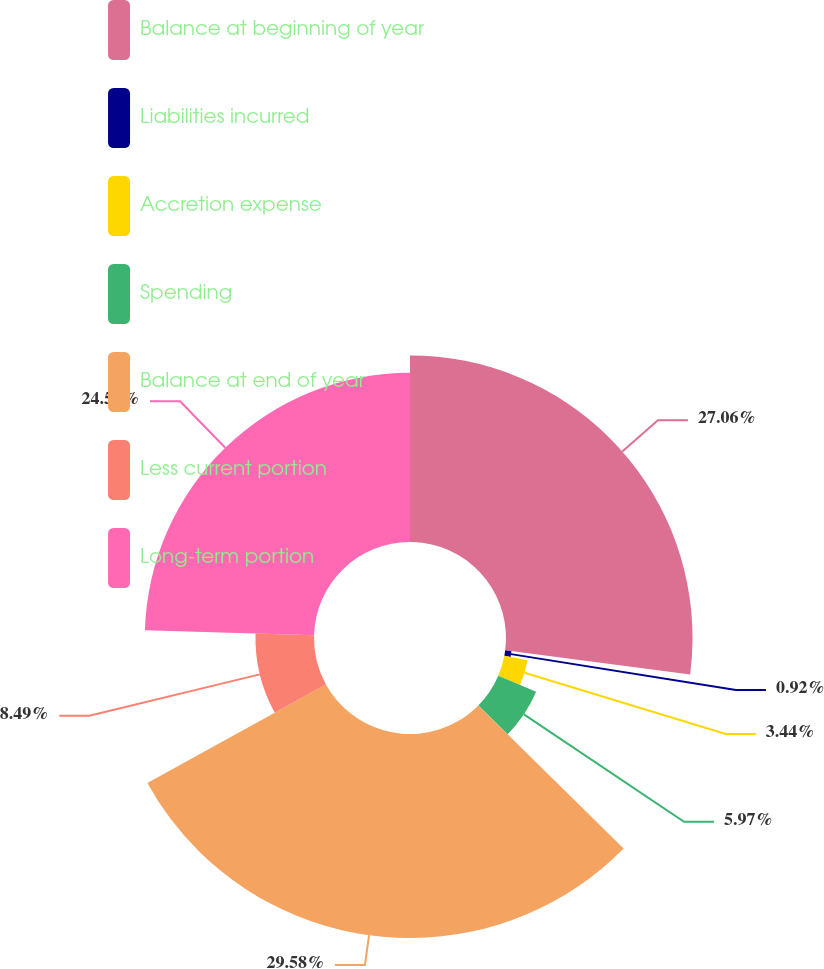Convert chart to OTSL. <chart><loc_0><loc_0><loc_500><loc_500><pie_chart><fcel>Balance at beginning of year<fcel>Liabilities incurred<fcel>Accretion expense<fcel>Spending<fcel>Balance at end of year<fcel>Less current portion<fcel>Long-term portion<nl><fcel>27.06%<fcel>0.92%<fcel>3.44%<fcel>5.97%<fcel>29.59%<fcel>8.49%<fcel>24.54%<nl></chart> 